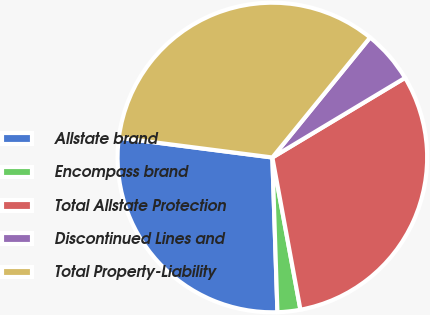Convert chart. <chart><loc_0><loc_0><loc_500><loc_500><pie_chart><fcel>Allstate brand<fcel>Encompass brand<fcel>Total Allstate Protection<fcel>Discontinued Lines and<fcel>Total Property-Liability<nl><fcel>27.56%<fcel>2.38%<fcel>30.7%<fcel>5.52%<fcel>33.84%<nl></chart> 